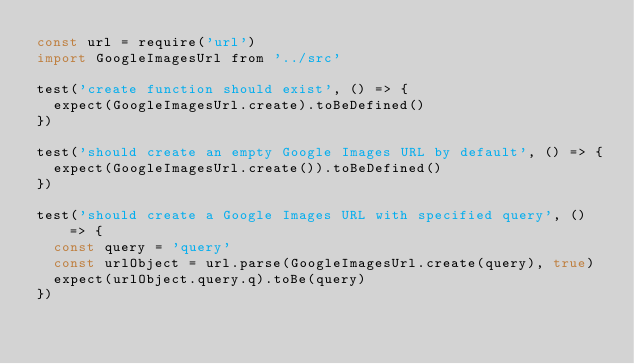Convert code to text. <code><loc_0><loc_0><loc_500><loc_500><_JavaScript_>const url = require('url')
import GoogleImagesUrl from '../src'

test('create function should exist', () => {
  expect(GoogleImagesUrl.create).toBeDefined()
})

test('should create an empty Google Images URL by default', () => {
  expect(GoogleImagesUrl.create()).toBeDefined()
})

test('should create a Google Images URL with specified query', () => {
  const query = 'query'
  const urlObject = url.parse(GoogleImagesUrl.create(query), true)
  expect(urlObject.query.q).toBe(query)
})
</code> 